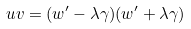Convert formula to latex. <formula><loc_0><loc_0><loc_500><loc_500>u v = ( w ^ { \prime } - \lambda \gamma ) ( w ^ { \prime } + \lambda \gamma )</formula> 